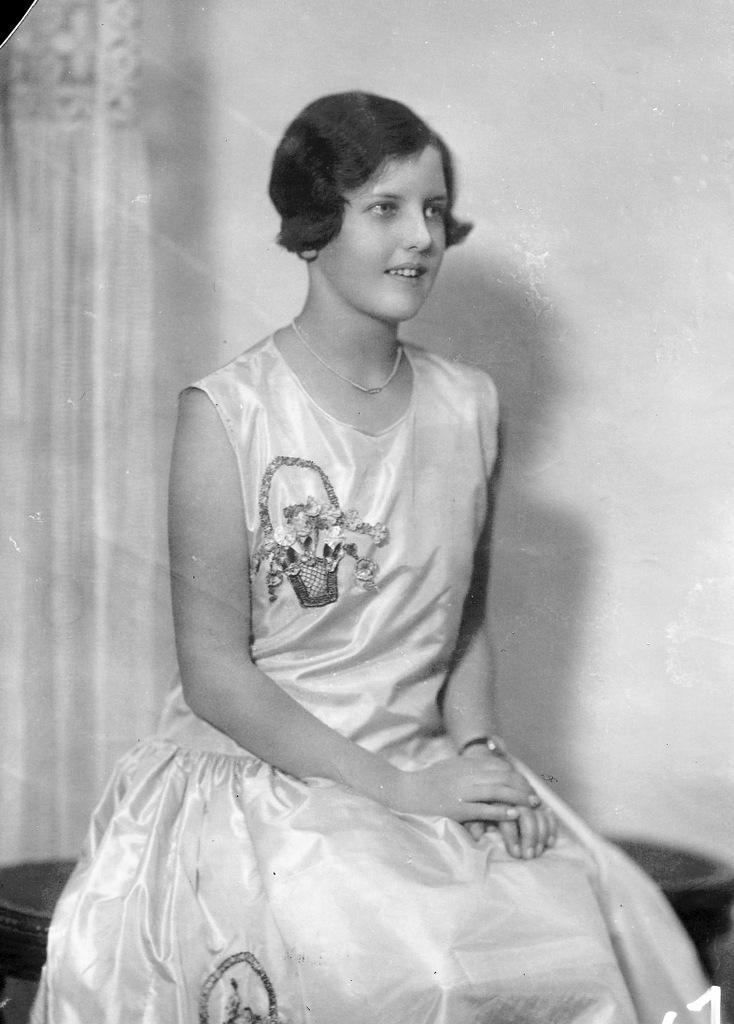Who is the main subject in the image? There is a girl in the image. What is the girl wearing? The girl is wearing a long dress. What is the girl doing in the image? The girl is sitting. What can be seen in the background of the image? There is a wall in the background of the image, and a curtain is associated with the wall. What type of meal is the girl preparing in the image? There is no indication in the image that the girl is preparing a meal, as she is simply sitting and not engaged in any food-related activities. 